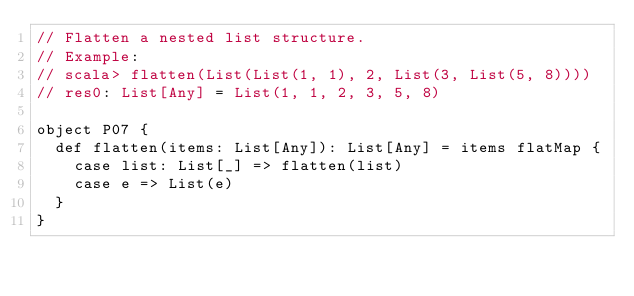<code> <loc_0><loc_0><loc_500><loc_500><_Scala_>// Flatten a nested list structure.
// Example:
// scala> flatten(List(List(1, 1), 2, List(3, List(5, 8))))
// res0: List[Any] = List(1, 1, 2, 3, 5, 8)

object P07 {
  def flatten(items: List[Any]): List[Any] = items flatMap {
    case list: List[_] => flatten(list)
    case e => List(e)
  }
}
</code> 